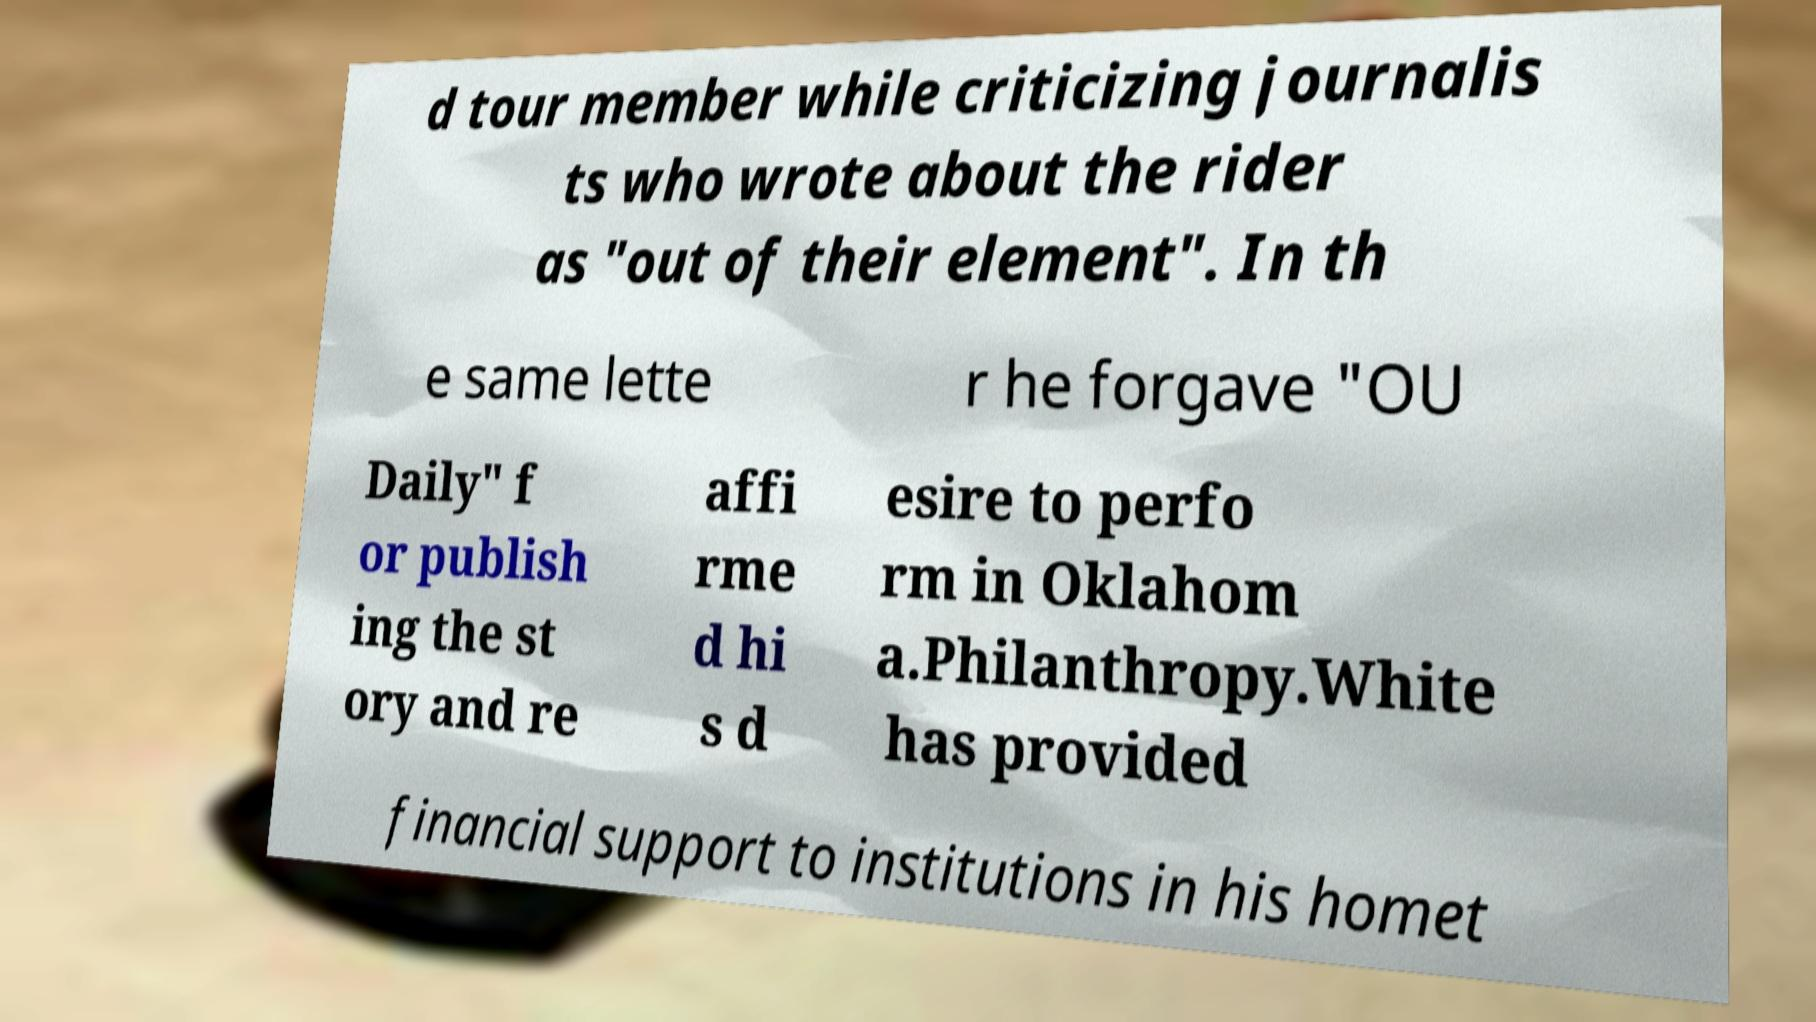I need the written content from this picture converted into text. Can you do that? d tour member while criticizing journalis ts who wrote about the rider as "out of their element". In th e same lette r he forgave "OU Daily" f or publish ing the st ory and re affi rme d hi s d esire to perfo rm in Oklahom a.Philanthropy.White has provided financial support to institutions in his homet 